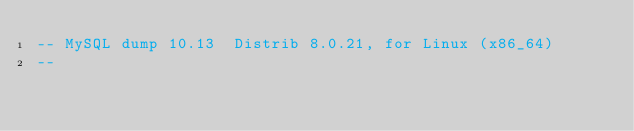Convert code to text. <code><loc_0><loc_0><loc_500><loc_500><_SQL_>-- MySQL dump 10.13  Distrib 8.0.21, for Linux (x86_64)
--</code> 